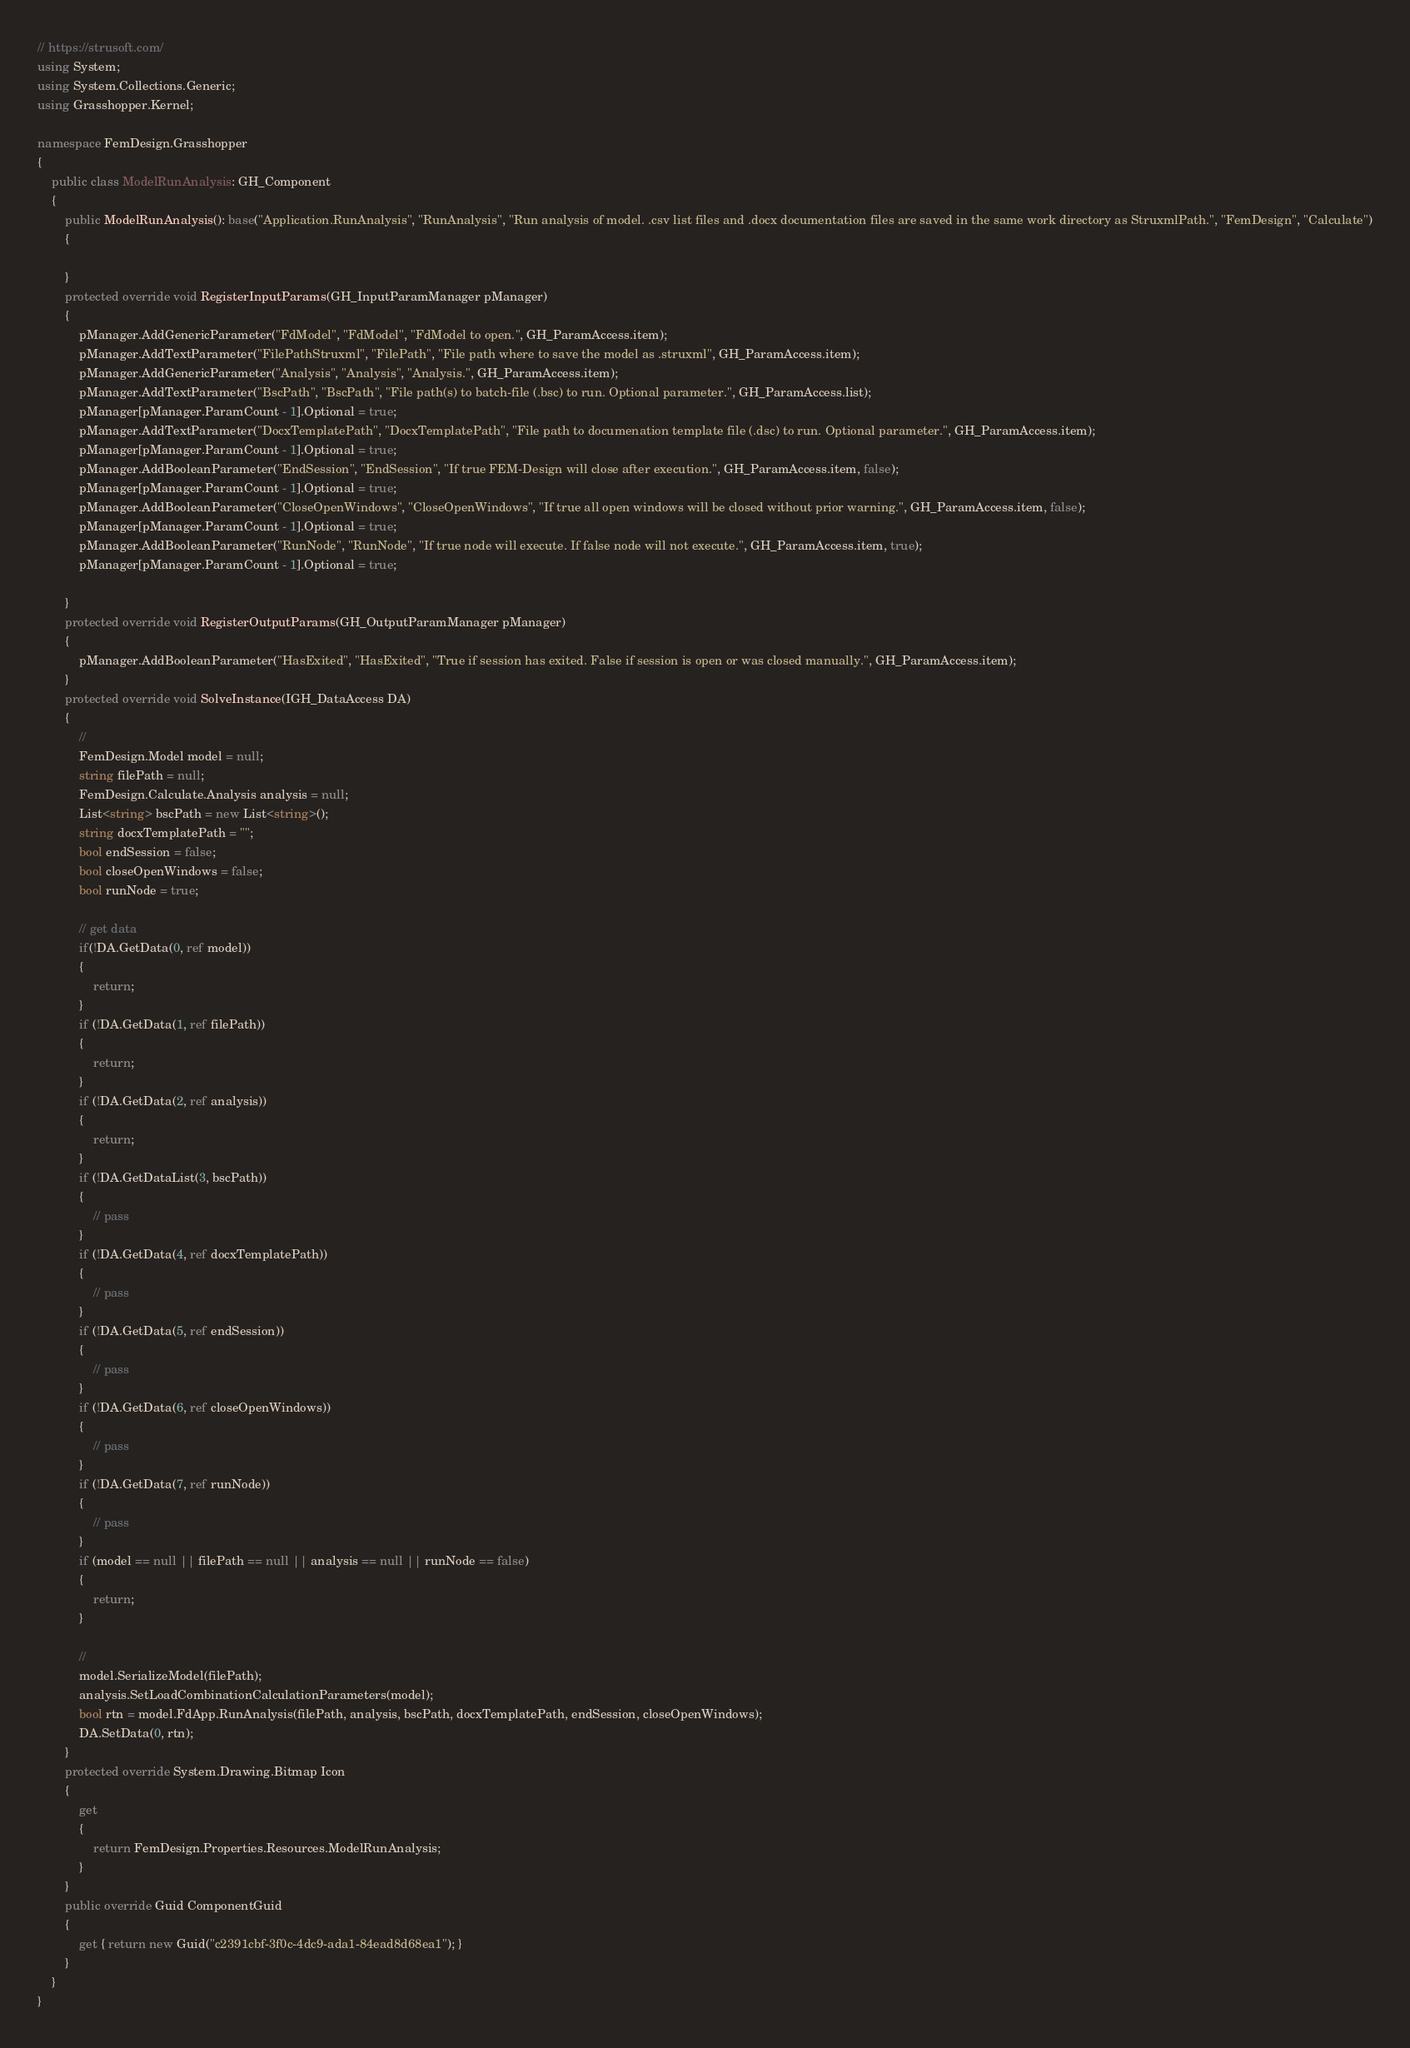Convert code to text. <code><loc_0><loc_0><loc_500><loc_500><_C#_>// https://strusoft.com/
using System;
using System.Collections.Generic;
using Grasshopper.Kernel;

namespace FemDesign.Grasshopper
{
    public class ModelRunAnalysis: GH_Component
    {
        public ModelRunAnalysis(): base("Application.RunAnalysis", "RunAnalysis", "Run analysis of model. .csv list files and .docx documentation files are saved in the same work directory as StruxmlPath.", "FemDesign", "Calculate")
        {

        }
        protected override void RegisterInputParams(GH_InputParamManager pManager)
        {
            pManager.AddGenericParameter("FdModel", "FdModel", "FdModel to open.", GH_ParamAccess.item);
            pManager.AddTextParameter("FilePathStruxml", "FilePath", "File path where to save the model as .struxml", GH_ParamAccess.item);
            pManager.AddGenericParameter("Analysis", "Analysis", "Analysis.", GH_ParamAccess.item);
            pManager.AddTextParameter("BscPath", "BscPath", "File path(s) to batch-file (.bsc) to run. Optional parameter.", GH_ParamAccess.list);
            pManager[pManager.ParamCount - 1].Optional = true;
            pManager.AddTextParameter("DocxTemplatePath", "DocxTemplatePath", "File path to documenation template file (.dsc) to run. Optional parameter.", GH_ParamAccess.item);
            pManager[pManager.ParamCount - 1].Optional = true;
            pManager.AddBooleanParameter("EndSession", "EndSession", "If true FEM-Design will close after execution.", GH_ParamAccess.item, false);
            pManager[pManager.ParamCount - 1].Optional = true;
            pManager.AddBooleanParameter("CloseOpenWindows", "CloseOpenWindows", "If true all open windows will be closed without prior warning.", GH_ParamAccess.item, false);
            pManager[pManager.ParamCount - 1].Optional = true;
            pManager.AddBooleanParameter("RunNode", "RunNode", "If true node will execute. If false node will not execute.", GH_ParamAccess.item, true);
            pManager[pManager.ParamCount - 1].Optional = true;

        }
        protected override void RegisterOutputParams(GH_OutputParamManager pManager)
        {
            pManager.AddBooleanParameter("HasExited", "HasExited", "True if session has exited. False if session is open or was closed manually.", GH_ParamAccess.item);
        }
        protected override void SolveInstance(IGH_DataAccess DA)
        {
            // 
            FemDesign.Model model = null;
            string filePath = null;
            FemDesign.Calculate.Analysis analysis = null;
            List<string> bscPath = new List<string>();
            string docxTemplatePath = "";
            bool endSession = false;
            bool closeOpenWindows = false;
            bool runNode = true;

            // get data
            if(!DA.GetData(0, ref model))
            {
                return;
            }
            if (!DA.GetData(1, ref filePath))
            {
                return;
            }
            if (!DA.GetData(2, ref analysis))
            {
                return;
            }
            if (!DA.GetDataList(3, bscPath))
            {
                // pass
            }
            if (!DA.GetData(4, ref docxTemplatePath))
            {
                // pass
            }
            if (!DA.GetData(5, ref endSession))
            {
                // pass
            }         
            if (!DA.GetData(6, ref closeOpenWindows))
            {
                // pass
            }
            if (!DA.GetData(7, ref runNode))
            {
                // pass
            }
            if (model == null || filePath == null || analysis == null || runNode == false)
            {
                return;
            }

            //
            model.SerializeModel(filePath);
            analysis.SetLoadCombinationCalculationParameters(model);
            bool rtn = model.FdApp.RunAnalysis(filePath, analysis, bscPath, docxTemplatePath, endSession, closeOpenWindows);
            DA.SetData(0, rtn);
        }
        protected override System.Drawing.Bitmap Icon
        {
            get
            {
                return FemDesign.Properties.Resources.ModelRunAnalysis;
            }
        }
        public override Guid ComponentGuid
        {
            get { return new Guid("c2391cbf-3f0c-4dc9-ada1-84ead8d68ea1"); }
        }
    }    
}</code> 